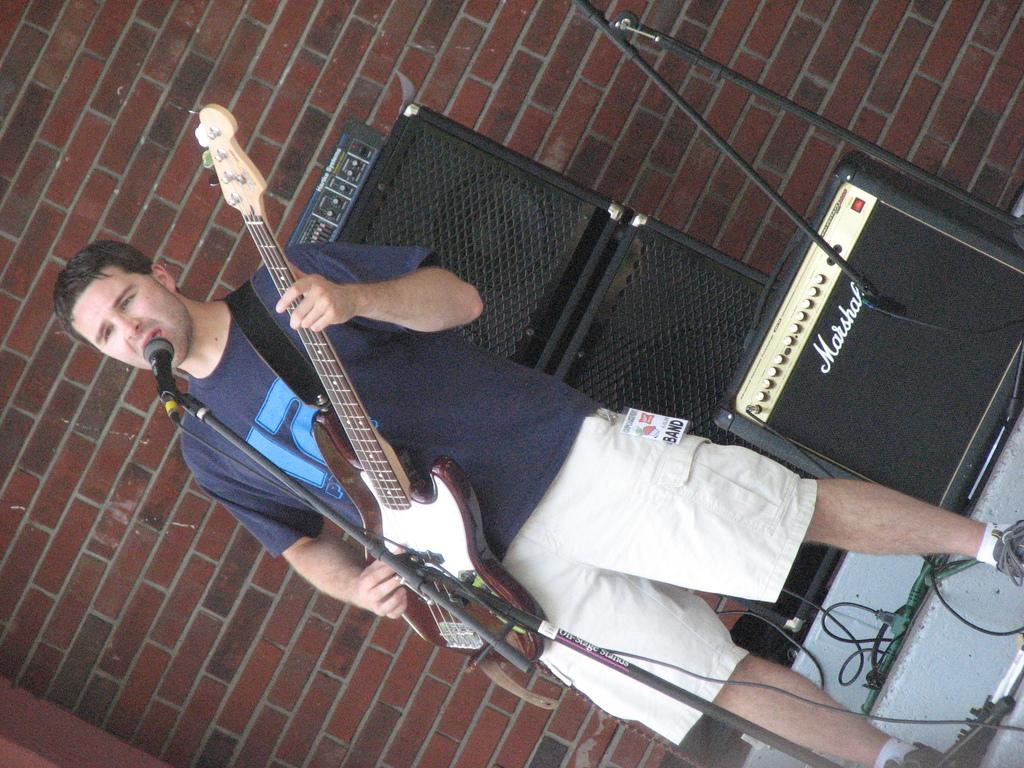What type of event is taking place in the image? The image appears to depict a music show. Can you describe the person performing in the image? There is a man in the image, and he is playing a guitar and singing a song. What can be seen in the background of the image? There are big speakers and a brick wall in the background. Where is the table located in the image? There is no table present in the image. What type of mine is visible in the background of the image? There is no mine present in the image; it depicts a music show with a brick wall in the background. 